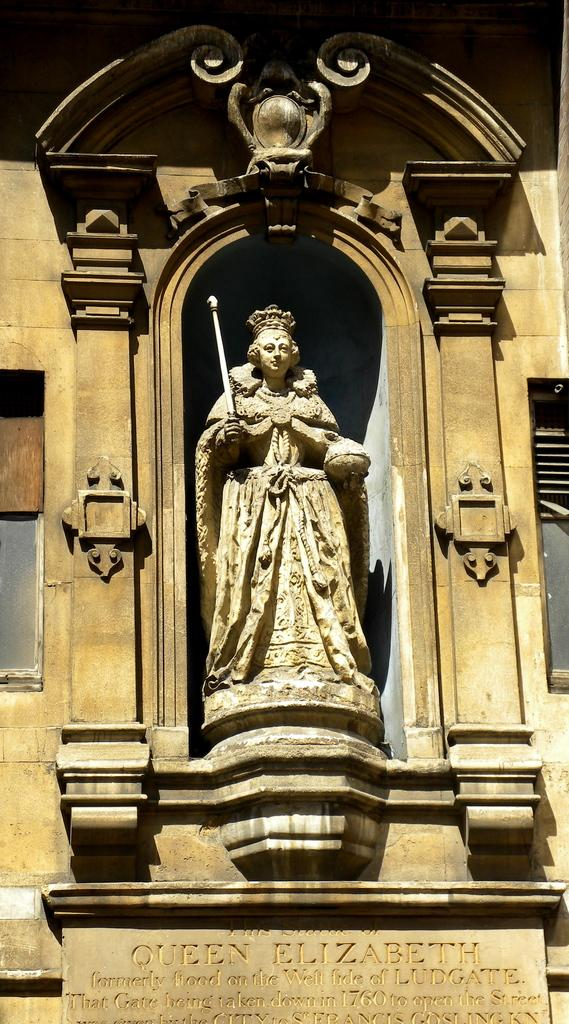What is the main subject in the image? There is a statue in the image. What else can be seen in the image besides the statue? There is a building in the image. What type of poison is being used to treat the tree in the image? There is no tree or poison present in the image; it only features a statue and a building. 